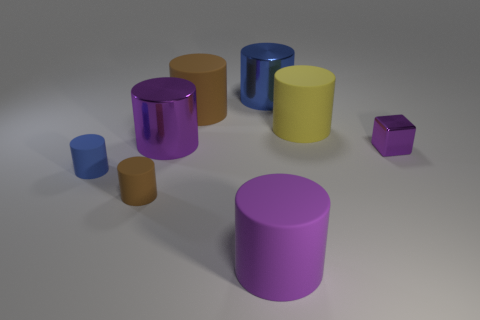What is the material of the big blue thing?
Make the answer very short. Metal. What is the size of the cylinder that is both to the right of the large brown object and behind the yellow cylinder?
Your response must be concise. Large. Are there any metallic cylinders right of the purple object on the right side of the big blue object?
Provide a short and direct response. No. What material is the large blue object that is the same shape as the big brown rubber thing?
Ensure brevity in your answer.  Metal. There is a big purple object in front of the block; what number of brown rubber cylinders are on the left side of it?
Your answer should be very brief. 2. How many objects are large blue metallic objects or large cylinders that are behind the purple shiny block?
Offer a terse response. 4. What material is the big brown cylinder behind the large matte cylinder that is in front of the brown cylinder that is in front of the large yellow matte object?
Provide a short and direct response. Rubber. There is a purple cylinder that is the same material as the yellow thing; what size is it?
Make the answer very short. Large. There is a large matte cylinder that is in front of the big cylinder that is right of the large blue shiny cylinder; what is its color?
Provide a short and direct response. Purple. How many other small blue cylinders are the same material as the tiny blue cylinder?
Your answer should be compact. 0. 